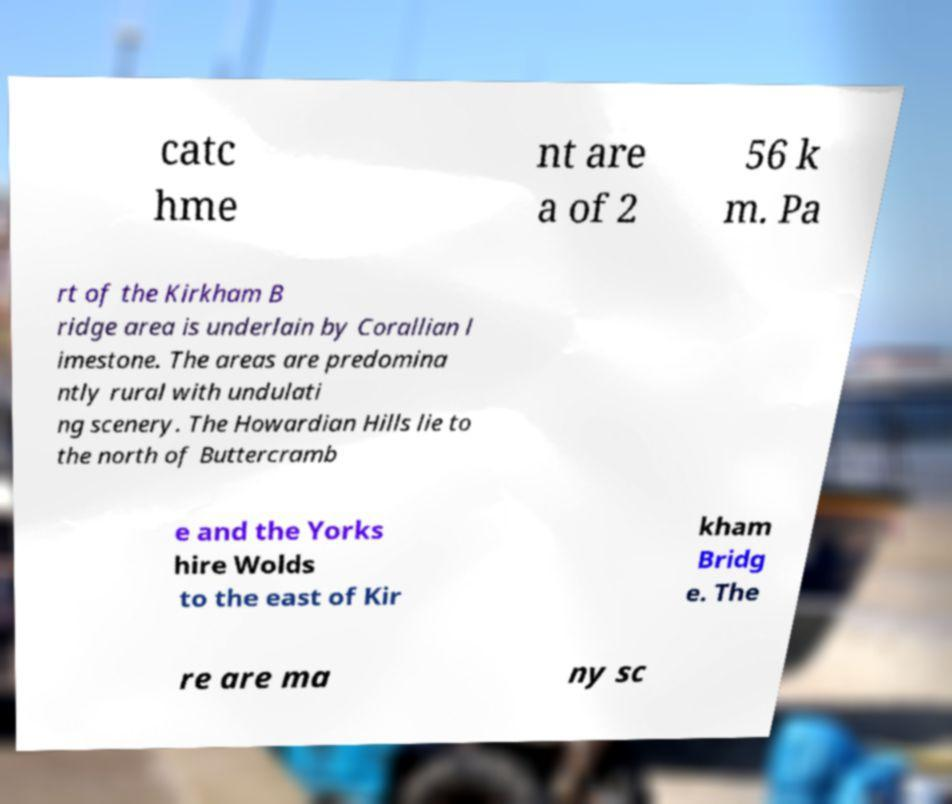Can you read and provide the text displayed in the image?This photo seems to have some interesting text. Can you extract and type it out for me? catc hme nt are a of 2 56 k m. Pa rt of the Kirkham B ridge area is underlain by Corallian l imestone. The areas are predomina ntly rural with undulati ng scenery. The Howardian Hills lie to the north of Buttercramb e and the Yorks hire Wolds to the east of Kir kham Bridg e. The re are ma ny sc 